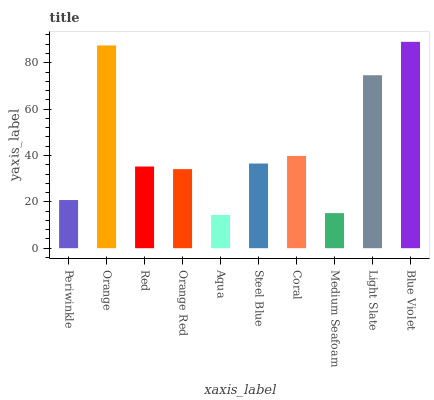Is Aqua the minimum?
Answer yes or no. Yes. Is Blue Violet the maximum?
Answer yes or no. Yes. Is Orange the minimum?
Answer yes or no. No. Is Orange the maximum?
Answer yes or no. No. Is Orange greater than Periwinkle?
Answer yes or no. Yes. Is Periwinkle less than Orange?
Answer yes or no. Yes. Is Periwinkle greater than Orange?
Answer yes or no. No. Is Orange less than Periwinkle?
Answer yes or no. No. Is Steel Blue the high median?
Answer yes or no. Yes. Is Red the low median?
Answer yes or no. Yes. Is Aqua the high median?
Answer yes or no. No. Is Orange Red the low median?
Answer yes or no. No. 